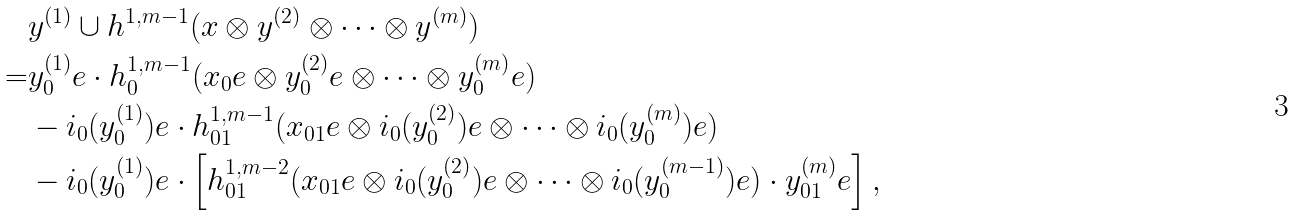Convert formula to latex. <formula><loc_0><loc_0><loc_500><loc_500>& y ^ { ( 1 ) } \cup h ^ { 1 , m - 1 } ( x \otimes y ^ { ( 2 ) } \otimes \cdots \otimes y ^ { ( m ) } ) \\ = & y ^ { ( 1 ) } _ { 0 } e \cdot h ^ { 1 , m - 1 } _ { 0 } ( x _ { 0 } e \otimes y ^ { ( 2 ) } _ { 0 } e \otimes \cdots \otimes y ^ { ( m ) } _ { 0 } e ) \\ & - i _ { 0 } ( y ^ { ( 1 ) } _ { 0 } ) e \cdot h ^ { 1 , m - 1 } _ { 0 1 } ( x _ { 0 1 } e \otimes i _ { 0 } ( y ^ { ( 2 ) } _ { 0 } ) e \otimes \cdots \otimes i _ { 0 } ( y ^ { ( m ) } _ { 0 } ) e ) \\ & - i _ { 0 } ( y ^ { ( 1 ) } _ { 0 } ) e \cdot \left [ h ^ { 1 , m - 2 } _ { 0 1 } ( x _ { 0 1 } e \otimes i _ { 0 } ( y ^ { ( 2 ) } _ { 0 } ) e \otimes \cdots \otimes i _ { 0 } ( y ^ { ( m - 1 ) } _ { 0 } ) e ) \cdot y _ { 0 1 } ^ { ( m ) } e \right ] ,</formula> 